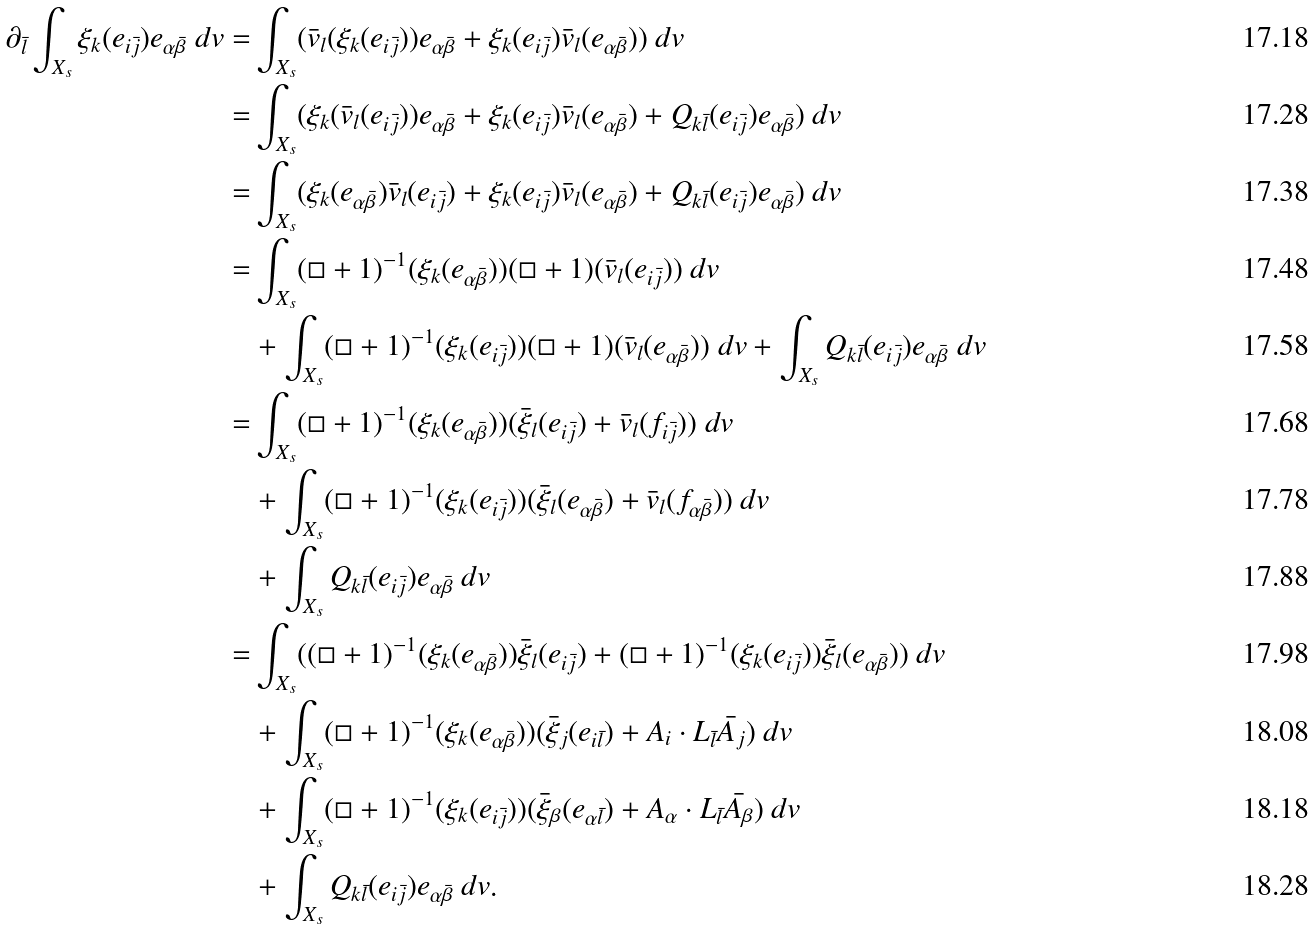<formula> <loc_0><loc_0><loc_500><loc_500>\partial _ { \bar { l } } \int _ { X _ { s } } \xi _ { k } ( e _ { i \bar { j } } ) e _ { \alpha \bar { \beta } } \ d v = & \int _ { X _ { s } } ( \bar { v } _ { l } ( \xi _ { k } ( e _ { i \bar { j } } ) ) e _ { \alpha \bar { \beta } } + \xi _ { k } ( e _ { i \bar { j } } ) \bar { v } _ { l } ( e _ { \alpha \bar { \beta } } ) ) \ d v \\ = & \int _ { X _ { s } } ( \xi _ { k } ( \bar { v } _ { l } ( e _ { i \bar { j } } ) ) e _ { \alpha \bar { \beta } } + \xi _ { k } ( e _ { i \bar { j } } ) \bar { v } _ { l } ( e _ { \alpha \bar { \beta } } ) + Q _ { k \bar { l } } ( e _ { i \bar { j } } ) e _ { \alpha \bar { \beta } } ) \ d v \\ = & \int _ { X _ { s } } ( \xi _ { k } ( e _ { \alpha \bar { \beta } } ) \bar { v } _ { l } ( e _ { i \bar { j } } ) + \xi _ { k } ( e _ { i \bar { j } } ) \bar { v } _ { l } ( e _ { \alpha \bar { \beta } } ) + Q _ { k \bar { l } } ( e _ { i \bar { j } } ) e _ { \alpha \bar { \beta } } ) \ d v \\ = & \int _ { X _ { s } } ( \Box + 1 ) ^ { - 1 } ( \xi _ { k } ( e _ { \alpha \bar { \beta } } ) ) ( \Box + 1 ) ( \bar { v } _ { l } ( e _ { i \bar { j } } ) ) \ d v \\ & + \int _ { X _ { s } } ( \Box + 1 ) ^ { - 1 } ( \xi _ { k } ( e _ { i \bar { j } } ) ) ( \Box + 1 ) ( \bar { v } _ { l } ( e _ { \alpha \bar { \beta } } ) ) \ d v + \int _ { X _ { s } } Q _ { k \bar { l } } ( e _ { i \bar { j } } ) e _ { \alpha \bar { \beta } } \ d v \\ = & \int _ { X _ { s } } ( \Box + 1 ) ^ { - 1 } ( \xi _ { k } ( e _ { \alpha \bar { \beta } } ) ) ( \bar { \xi } _ { l } ( e _ { i \bar { j } } ) + \bar { v } _ { l } ( f _ { i \bar { j } } ) ) \ d v \\ & + \int _ { X _ { s } } ( \Box + 1 ) ^ { - 1 } ( \xi _ { k } ( e _ { i \bar { j } } ) ) ( \bar { \xi } _ { l } ( e _ { \alpha \bar { \beta } } ) + \bar { v } _ { l } ( f _ { \alpha \bar { \beta } } ) ) \ d v \\ & + \int _ { X _ { s } } Q _ { k \bar { l } } ( e _ { i \bar { j } } ) e _ { \alpha \bar { \beta } } \ d v \\ = & \int _ { X _ { s } } ( ( \Box + 1 ) ^ { - 1 } ( \xi _ { k } ( e _ { \alpha \bar { \beta } } ) ) \bar { \xi } _ { l } ( e _ { i \bar { j } } ) + ( \Box + 1 ) ^ { - 1 } ( \xi _ { k } ( e _ { i \bar { j } } ) ) \bar { \xi } _ { l } ( e _ { \alpha \bar { \beta } } ) ) \ d v \\ & + \int _ { X _ { s } } ( \Box + 1 ) ^ { - 1 } ( \xi _ { k } ( e _ { \alpha \bar { \beta } } ) ) ( \bar { \xi } _ { j } ( e _ { i \bar { l } } ) + A _ { i } \cdot L _ { \bar { l } } \bar { A _ { j } } ) \ d v \\ & + \int _ { X _ { s } } ( \Box + 1 ) ^ { - 1 } ( \xi _ { k } ( e _ { i \bar { j } } ) ) ( \bar { \xi } _ { \beta } ( e _ { \alpha \bar { l } } ) + A _ { \alpha } \cdot L _ { \bar { l } } \bar { A _ { \beta } } ) \ d v \\ & + \int _ { X _ { s } } Q _ { k \bar { l } } ( e _ { i \bar { j } } ) e _ { \alpha \bar { \beta } } \ d v .</formula> 